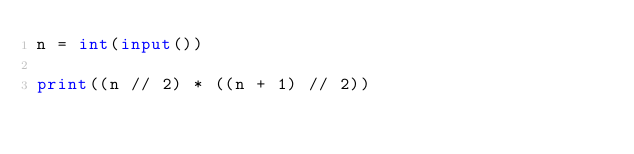Convert code to text. <code><loc_0><loc_0><loc_500><loc_500><_Python_>n = int(input())

print((n // 2) * ((n + 1) // 2))</code> 